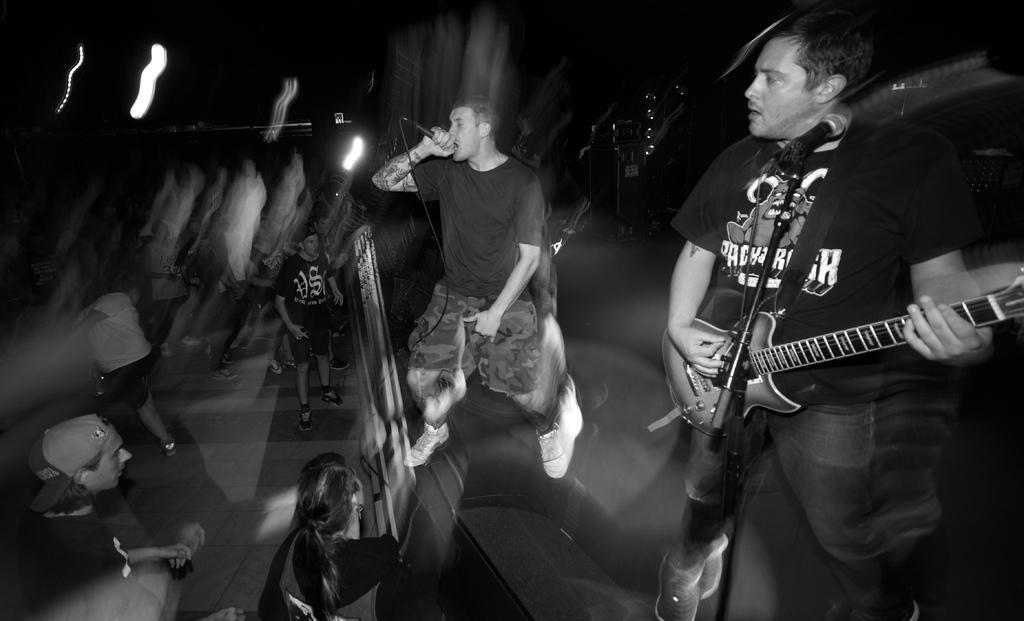Could you give a brief overview of what you see in this image? There are two men standing. This man is standing and singing a song using mike and the other man is standing and playing guitar. I can see group of people standing and watching their performance. This is the mike with the mike stand. 